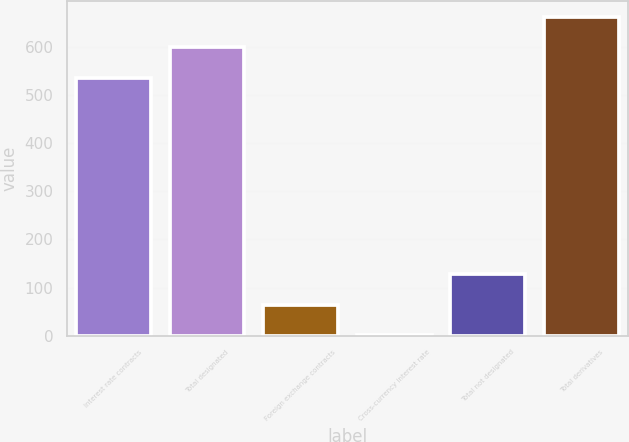<chart> <loc_0><loc_0><loc_500><loc_500><bar_chart><fcel>Interest rate contracts<fcel>Total designated<fcel>Foreign exchange contracts<fcel>Cross-currency interest rate<fcel>Total not designated<fcel>Total derivatives<nl><fcel>536<fcel>599.6<fcel>64.6<fcel>1<fcel>128.2<fcel>663.2<nl></chart> 